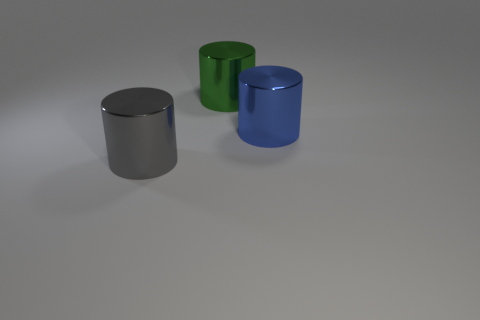Is the shape of the green shiny object the same as the thing that is on the left side of the green metal cylinder? Yes, the green shiny object has the same cylindrical shape as the object on its left side, which also appears to be a cylinder with a metallic finish. 